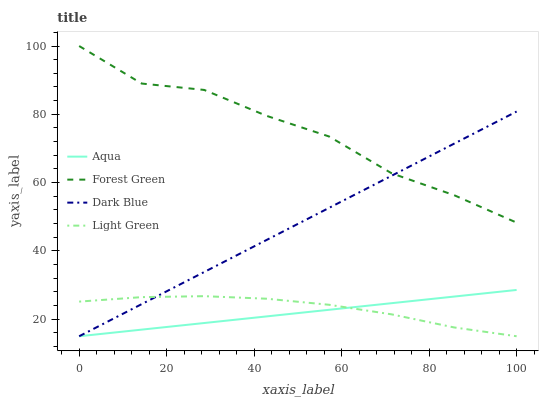Does Aqua have the minimum area under the curve?
Answer yes or no. Yes. Does Forest Green have the maximum area under the curve?
Answer yes or no. Yes. Does Forest Green have the minimum area under the curve?
Answer yes or no. No. Does Aqua have the maximum area under the curve?
Answer yes or no. No. Is Aqua the smoothest?
Answer yes or no. Yes. Is Forest Green the roughest?
Answer yes or no. Yes. Is Forest Green the smoothest?
Answer yes or no. No. Is Aqua the roughest?
Answer yes or no. No. Does Dark Blue have the lowest value?
Answer yes or no. Yes. Does Forest Green have the lowest value?
Answer yes or no. No. Does Forest Green have the highest value?
Answer yes or no. Yes. Does Aqua have the highest value?
Answer yes or no. No. Is Aqua less than Forest Green?
Answer yes or no. Yes. Is Forest Green greater than Light Green?
Answer yes or no. Yes. Does Dark Blue intersect Light Green?
Answer yes or no. Yes. Is Dark Blue less than Light Green?
Answer yes or no. No. Is Dark Blue greater than Light Green?
Answer yes or no. No. Does Aqua intersect Forest Green?
Answer yes or no. No. 